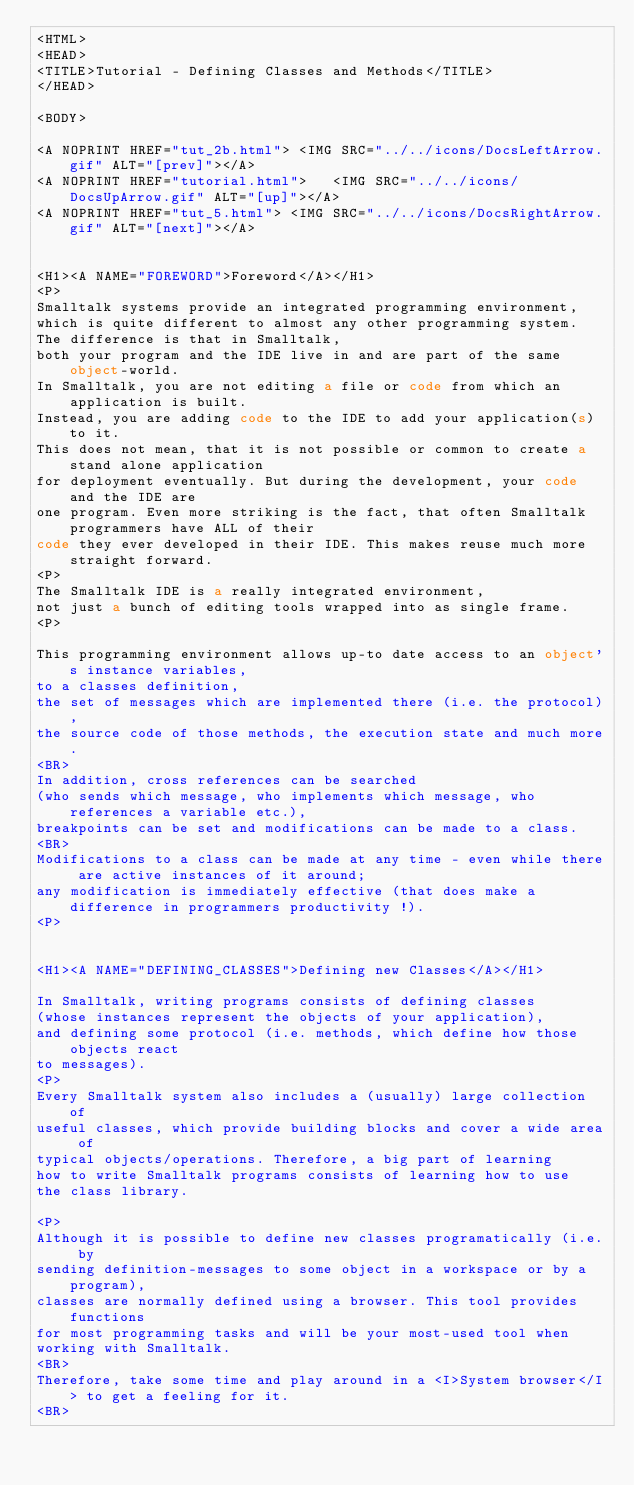<code> <loc_0><loc_0><loc_500><loc_500><_HTML_><HTML>
<HEAD>
<TITLE>Tutorial - Defining Classes and Methods</TITLE>
</HEAD>

<BODY>

<A NOPRINT HREF="tut_2b.html"> <IMG SRC="../../icons/DocsLeftArrow.gif" ALT="[prev]"></A>
<A NOPRINT HREF="tutorial.html">   <IMG SRC="../../icons/DocsUpArrow.gif" ALT="[up]"></A>
<A NOPRINT HREF="tut_5.html"> <IMG SRC="../../icons/DocsRightArrow.gif" ALT="[next]"></A>


<H1><A NAME="FOREWORD">Foreword</A></H1>
<P>
Smalltalk systems provide an integrated programming environment,
which is quite different to almost any other programming system.
The difference is that in Smalltalk,
both your program and the IDE live in and are part of the same object-world.
In Smalltalk, you are not editing a file or code from which an application is built.
Instead, you are adding code to the IDE to add your application(s) to it.
This does not mean, that it is not possible or common to create a stand alone application
for deployment eventually. But during the development, your code and the IDE are
one program. Even more striking is the fact, that often Smalltalk programmers have ALL of their
code they ever developed in their IDE. This makes reuse much more straight forward.
<P>
The Smalltalk IDE is a really integrated environment,
not just a bunch of editing tools wrapped into as single frame.
<P>

This programming environment allows up-to date access to an object's instance variables,
to a classes definition,
the set of messages which are implemented there (i.e. the protocol),
the source code of those methods, the execution state and much more.
<BR>
In addition, cross references can be searched
(who sends which message, who implements which message, who references a variable etc.),
breakpoints can be set and modifications can be made to a class.
<BR>
Modifications to a class can be made at any time - even while there are active instances of it around;
any modification is immediately effective (that does make a difference in programmers productivity !).
<P>


<H1><A NAME="DEFINING_CLASSES">Defining new Classes</A></H1>

In Smalltalk, writing programs consists of defining classes
(whose instances represent the objects of your application),
and defining some protocol (i.e. methods, which define how those objects react
to messages).
<P>
Every Smalltalk system also includes a (usually) large collection of
useful classes, which provide building blocks and cover a wide area of
typical objects/operations. Therefore, a big part of learning
how to write Smalltalk programs consists of learning how to use
the class library.

<P>
Although it is possible to define new classes programatically (i.e. by
sending definition-messages to some object in a workspace or by a program),
classes are normally defined using a browser. This tool provides functions
for most programming tasks and will be your most-used tool when
working with Smalltalk.
<BR>
Therefore, take some time and play around in a <I>System browser</I> to get a feeling for it.
<BR></code> 